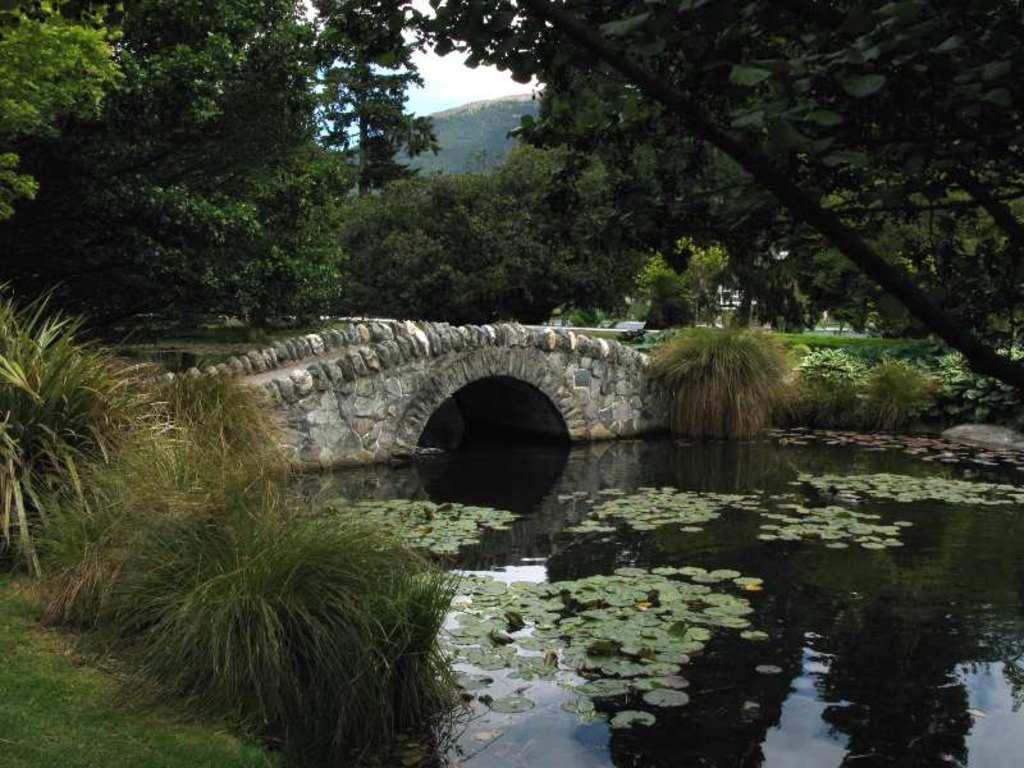Can you describe this image briefly? This picture shows few trees and we see a foot over bridge and water and we see a cloudy sky. 